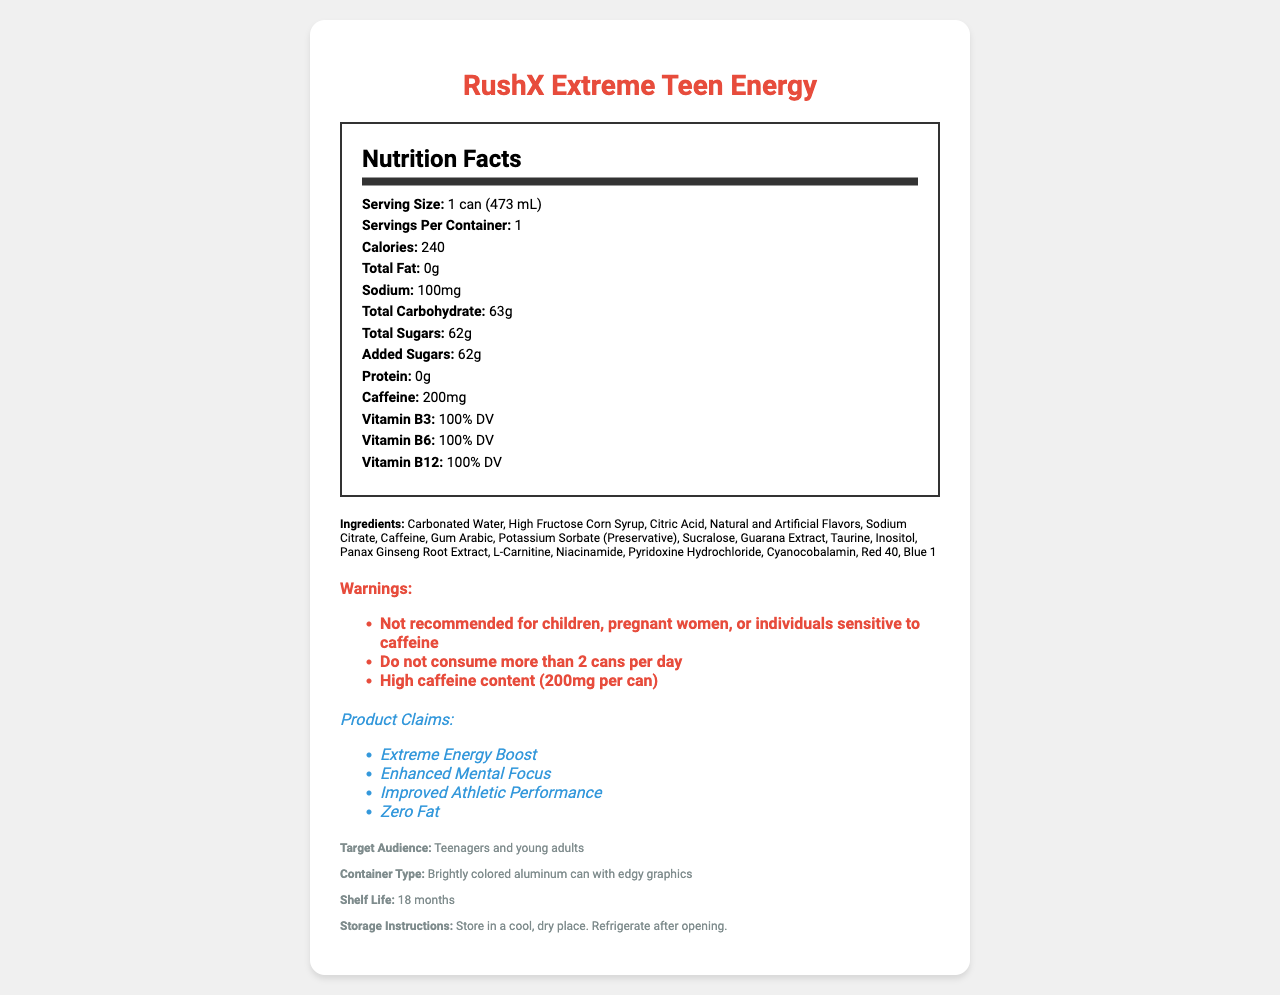what is the product name? The product name is prominently displayed at the top of the document.
Answer: RushX Extreme Teen Energy what is the serving size of RushX Extreme Teen Energy? The serving size is specified in the nutrition facts section of the document.
Answer: 1 can (473 mL) what is the total carbohydrate content per serving? The total carbohydrate content is listed in the nutrition facts section.
Answer: 63g what is the caffeine content per can? The caffeine content is clearly stated in the nutrition facts section.
Answer: 200mg how much added sugar does one can contain? The amount of added sugars is provided in the nutrition facts section.
Answer: 62g which vitamins are present and what is their daily value percentage? The vitamins and their daily values are outlined in the nutrition facts section.
Answer: Vitamin B3, Vitamin B6, and Vitamin B12, all at 100% DV which ingredient is listed first? Ingredients are listed in descending order by weight, with Carbonated Water appearing first.
Answer: Carbonated Water who is the target audience for this energy drink? The target audience is mentioned in the additional information section.
Answer: Teenagers and young adults how much sodium is in one can? The sodium content per serving is specified in the nutrition facts section.
Answer: 100mg are there any warnings regarding who should not consume this drink? The warnings clearly state that children, pregnant women, or individuals sensitive to caffeine should not consume this drink.
Answer: Yes how many calories are in one serving of RushX Extreme Teen Energy? The calorie content is listed in the nutrition facts section.
Answer: 240 what type of container is used for this product? The container type is mentioned in the additional information section.
Answer: Brightly colored aluminum can with edgy graphics how long is the shelf life of this product? The shelf life is provided in the additional information section.
Answer: 18 months what is the main idea of the document? The document includes details such as serving size, calories, ingredient list, and specific warnings, giving a comprehensive overview of the product.
Answer: The document provides detailed nutritional information, ingredients, warnings, and marketing claims for RushX Extreme Teen Energy, a high-caffeine beverage targeted towards teenagers and young adults. does this energy drink have zero fat? The nutrition facts section clearly states that the total fat content is 0g.
Answer: Yes which color additives are used in this drink? A. Blue 1 B. Red 40 C. Yellow 5 D. Both A and B The ingredient list includes both Red 40 and Blue 1 as color additives.
Answer: D what is the caffeine limit recommended in the warnings? A. 1 can per day B. 2 cans per day C. 3 cans per day D. No limit The warnings section states not to consume more than 2 cans per day.
Answer: B why might teenagers be attracted to this energy drink? The marketing claims and the design of the container seem to be crafted to attract a younger audience.
Answer: The marketing claims of "Extreme Energy Boost," "Enhanced Mental Focus," and "Improved Athletic Performance" coupled with the edgy graphics might be appealing to teenagers. is it safe for children to consume this energy drink? The warnings explicitly state that it is not recommended for children.
Answer: No how should the can be stored after opening? The storage instructions indicate that the can should be refrigerated after opening.
Answer: Refrigerate after opening what is the amount of protein in this energy drink? The protein content is listed as 0g in the nutrition facts section.
Answer: 0g what is the effect of the presence of high fructose corn syrup in the ingredient list? The document does not provide information on the specific effects of high fructose corn syrup.
Answer: Cannot be determined 